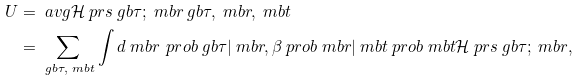Convert formula to latex. <formula><loc_0><loc_0><loc_500><loc_500>U & = \ a v g { \mathcal { H } \ p r s { \ g b { \tau } ; \ m b { r } } } { \ g b { \tau } , \ m b { r } , \ m b { t } } \\ & = \sum _ { \ g b { \tau } , \ m b { t } } \int d \ m b { r } \, \ p r o b { \ g b { \tau } | \ m b { r } , \beta } \ p r o b { \ m b { r } | \ m b { t } } \ p r o b { \ m b { t } } \mathcal { H } \ p r s { \ g b { \tau } ; \ m b { r } } ,</formula> 